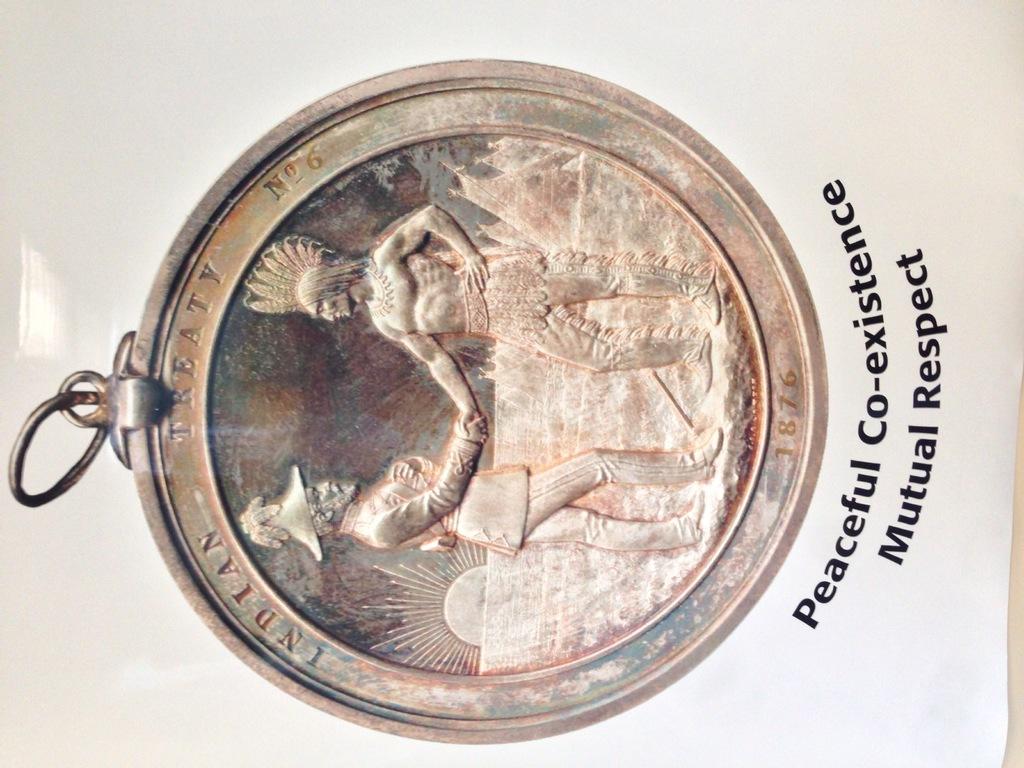What two words are at the top of this coin?
Provide a succinct answer. Indian treaty. 